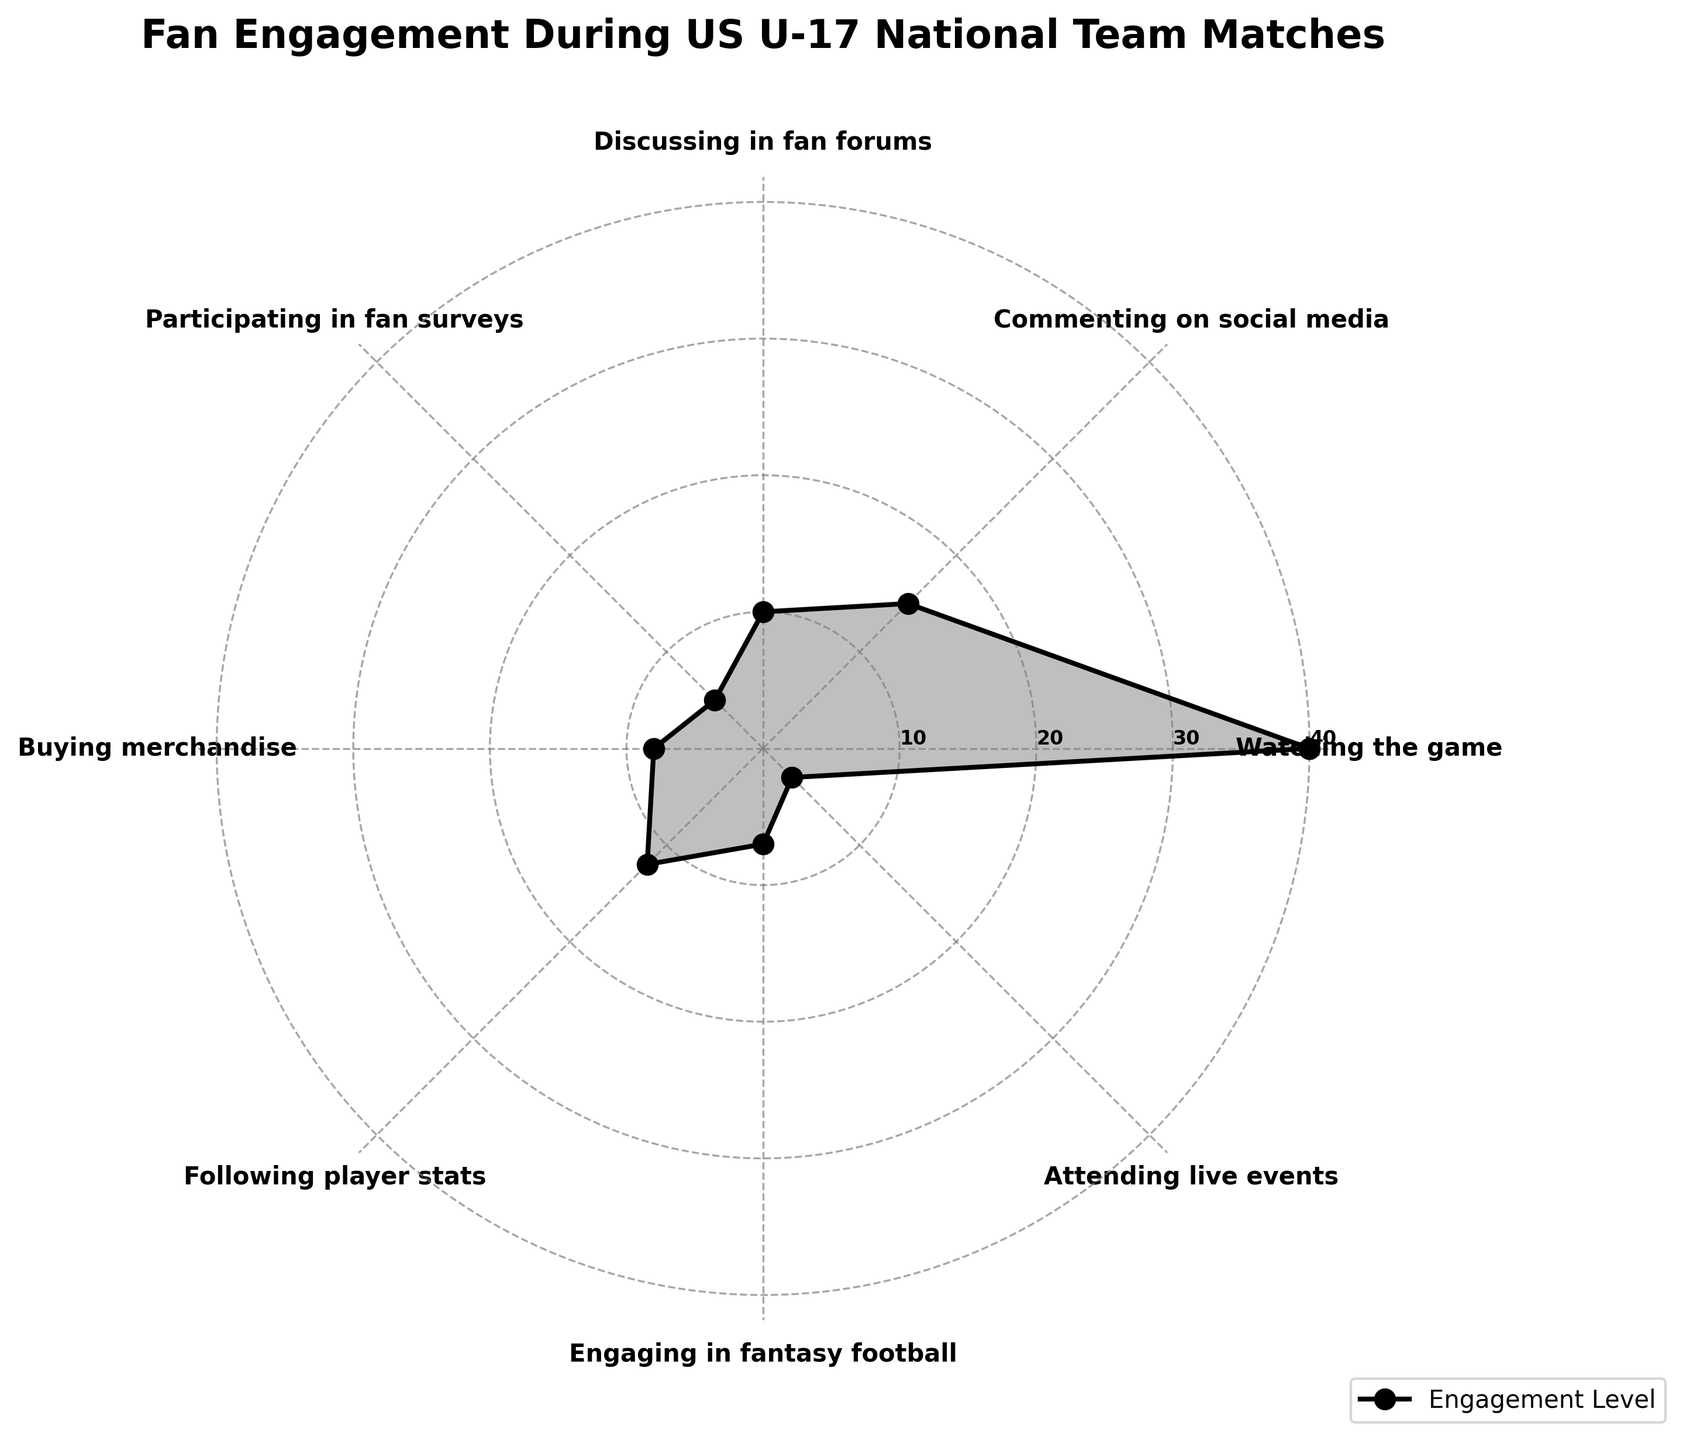what is the title of the chart? The title of the chart is located at the top and is written to summarize the chart's content.
Answer: Fan Engagement During US U-17 National Team Matches What category has the highest engagement? By observing the data points that spread outwards from the center, the category with the largest radial distance represents the highest engagement.
Answer: Watching the game Which category has the lowest engagement? Look for the data point closest to the center, indicating the smallest value.
Answer: Attending live events What is the range of engagement values? The range is found by subtracting the smallest engagement value from the largest engagement value. Here, it is from Watching the game (40) to Attending live events (3), so 40 - 3.
Answer: 37 How many categories have over 10 engagements? Count the number of categories where their data points lie beyond the 10 engagement ring.
Answer: 4 Which two categories have an equal engagement of 7 and 8, respectively? By examining the radial distances and matching them to their labels, identify the categories with engagements of both 7 and 8.
Answer: Engaging in fantasy football and Buying merchandise What is the average engagement for activities with more than 10 engagements? First identify the categories with more than 10 engagements: Watching the game (40), Commenting on social media (15), Following player stats (12). Sum these and divide by the number of categories. (40 + 15 + 12) / 3.
Answer: 22.33 Is the engagement in participating in fan surveys greater or less than buying merchandise? Compare the radial distances representing the two activities. Participating in fan surveys has an engagement of 5, while buying merchandise has 8.
Answer: Less What activities have an engagement exactly twice that of attending live events? Attending live events have an engagement of 3. Double this value to get 6. There are no activities with exactly 6 engagements.
Answer: None 